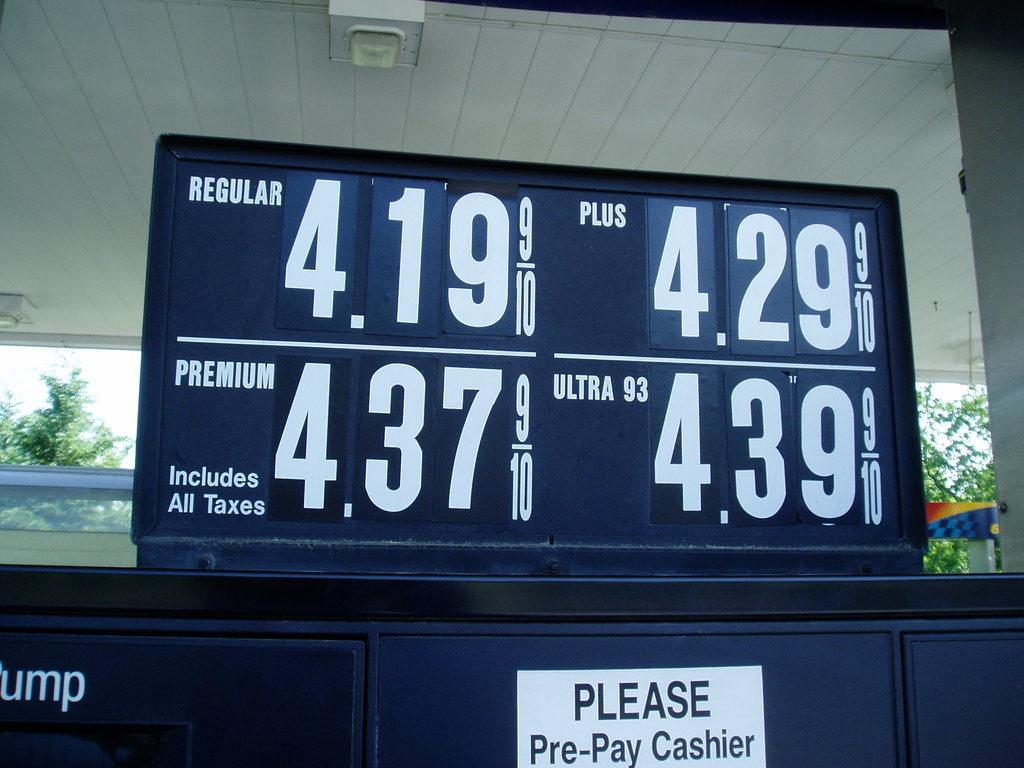What is the price of premium?
Offer a very short reply. 4.37. What is the price of plus?
Your response must be concise. 4.29. 